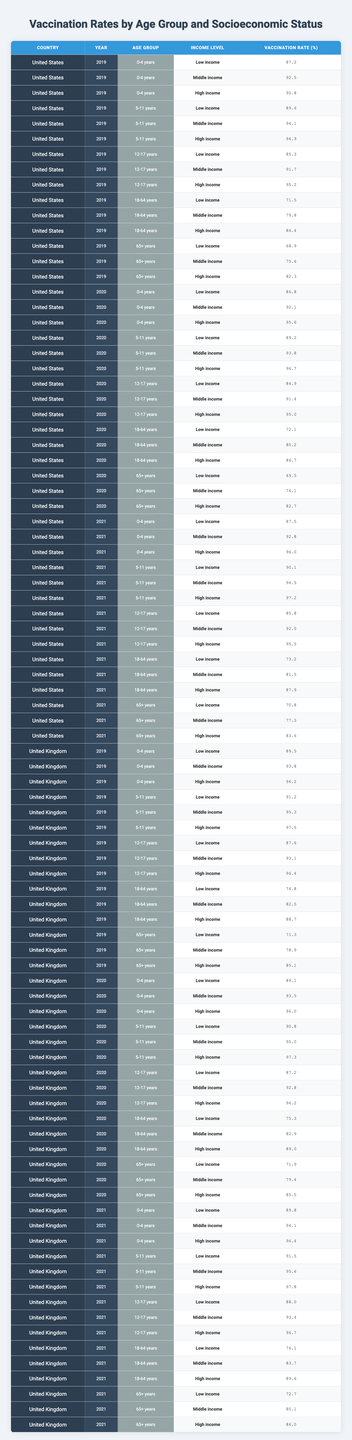What was the vaccination rate for '5-11 years' in the United States in 2020 for low-income families? The table shows that the vaccination rate for the age group '5-11 years' in the United States for low-income families in 2020 is 89.2%.
Answer: 89.2% What is the highest vaccination rate among high-income individuals aged 65+ years across the three years in the United Kingdom? By examining the table, the highest vaccination rate for high-income individuals aged 65+ years in the United Kingdom is 86.0% in 2021.
Answer: 86.0% How do vaccination rates compare for 0-4 years old between low-income groups in the United States and the United Kingdom in 2019? In 2019, the vaccination rate for low-income 0-4 year olds in the United States was 87.2%, while in the United Kingdom, it was 89.5%. The UK rate is higher by 2.3%.
Answer: UK: 89.5%, US: 87.2% What is the average vaccination rate for middle-income individuals across all age groups in the United States for the year 2021? The rates for middle-income individuals in 2021 are: 92.8 (0-4) + 94.5 (5-11) + 92.0 (12-17) + 81.5 (18-64) + 77.3 (65+) = 438.1. There are 5 age groups, so the average is 438.1 / 5 = 87.62%.
Answer: 87.62% Was the vaccination rate for low-income 18-64 year olds in the United Kingdom higher than in the United States in 2020? The low-income vaccination rates for 18-64 year olds are 72.1% in the United States and 75.3% in the United Kingdom in 2020. Since 75.3% > 72.1%, the answer is yes.
Answer: Yes What was the difference in vaccination rates for high-income 12-17 year olds between the United States and the United Kingdom in 2021? In 2021, the high-income vaccination rate for 12-17 year olds was 95.5% in the United States and 96.7% in the United Kingdom. The difference is 96.7% - 95.5% = 1.2%.
Answer: 1.2% Which age group shows the lowest vaccination rate for low-income families in the United States across 2019, 2020, and 2021? The vaccination rates for low-income families and the age group '18-64 years' are 71.5% (2019), 72.1% (2020), and 73.2% (2021). 71.5% is the lowest among these rates.
Answer: 71.5% Is it true that middle-income individuals aged 65+ years have the same vaccination rate in 2020 for both the United States and the United Kingdom? For 2020, the middle-income vaccination rate for 65+ year olds is 76.1% in the United States and 79.4% in the United Kingdom. Since these percentages are different, the answer is false.
Answer: False What was the pattern observed in vaccination rates for the '18-64 years' age group in the United States from 2019 to 2021? The vaccination rates for '18-64 years' in the United States increased from 71.5% in 2019 to 73.2% in 2021, showing a steady upward trend.
Answer: Steady increase What is the overall trend in vaccination rates for high-income individuals across the age groups from 2019 to 2021 in the United States? By analyzing the data, the vaccination rates for high-income individuals generally increased across all age groups from 2019 to 2021, indicating a positive trend in vaccination coverage.
Answer: Overall increase 